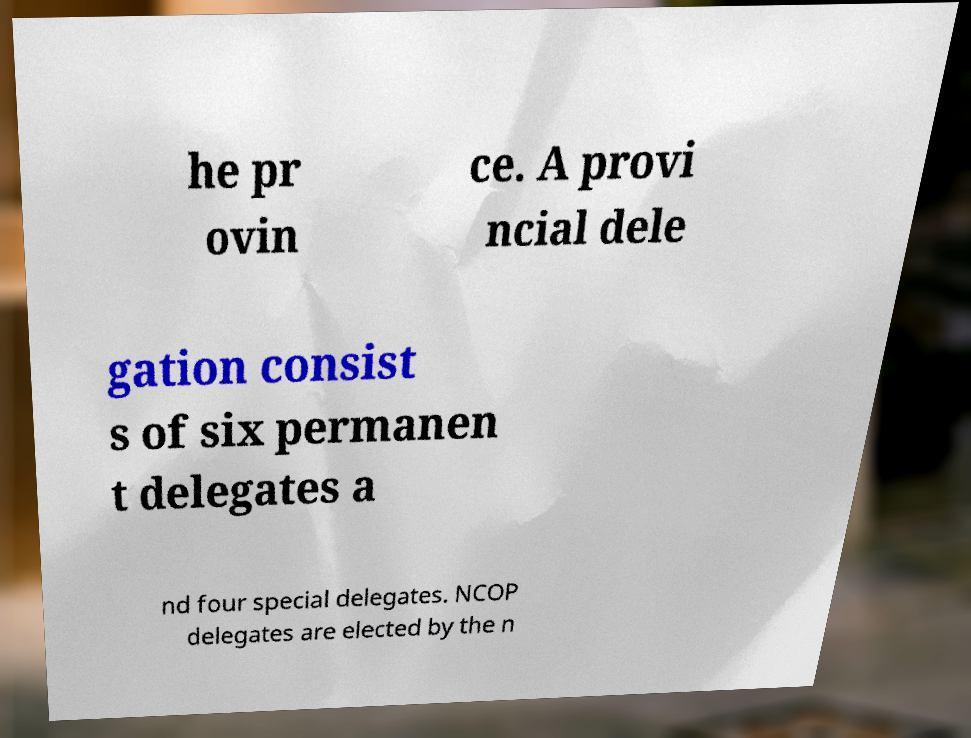Please read and relay the text visible in this image. What does it say? he pr ovin ce. A provi ncial dele gation consist s of six permanen t delegates a nd four special delegates. NCOP delegates are elected by the n 